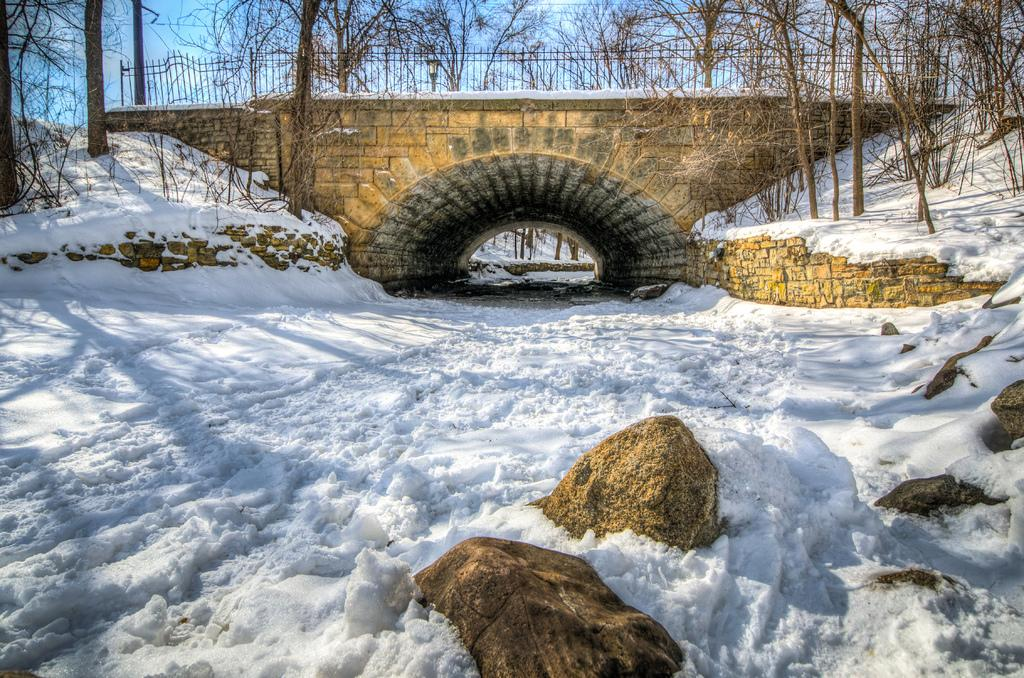What is the general appearance of the land in the image? The land in the image is covered with snow. What structure can be seen in the background of the image? There is a bridge in the background of the image. What feature does the bridge have? The bridge has railing. What type of natural elements can be seen in the background of the image? There are trees visible in the background of the image. Reasoning: Let' Let's think step by step in order to produce the conversation. We start by describing the overall appearance of the land, which is covered in snow. Then, we shift our focus to the background of the image, where we identify the presence of a bridge. We continue by describing a specific feature of the bridge, which is its railing. Finally, we mention the presence of trees in the background, which adds to the overall setting of the image. Absurd Question/Answer: What title is given to the stretch of pipe visible in the image? There is no stretch of pipe present in the image; it features a snow-covered land with a bridge and trees in the background. What type of title is given to the stretch of pipe visible in the image? There is no stretch of pipe present in the image; it features a snow-covered land with a bridge and trees in the background. 